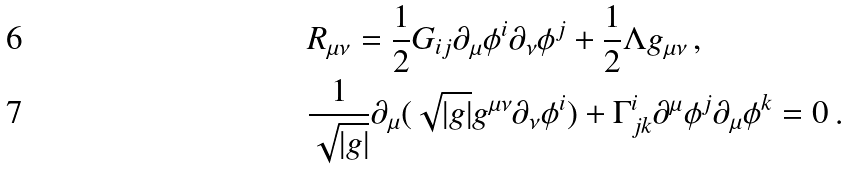<formula> <loc_0><loc_0><loc_500><loc_500>& R _ { \mu \nu } = \frac { 1 } { 2 } G _ { i j } \partial _ { \mu } \phi ^ { i } \partial _ { \nu } \phi ^ { j } + \frac { 1 } { 2 } \Lambda g _ { \mu \nu } \, , \\ & \frac { 1 } { \sqrt { | g | } } \partial _ { \mu } ( \sqrt { | g | } g ^ { \mu \nu } \partial _ { \nu } \phi ^ { i } ) + \Gamma ^ { i } _ { j k } \partial ^ { \mu } \phi ^ { j } \partial _ { \mu } \phi ^ { k } = 0 \, .</formula> 